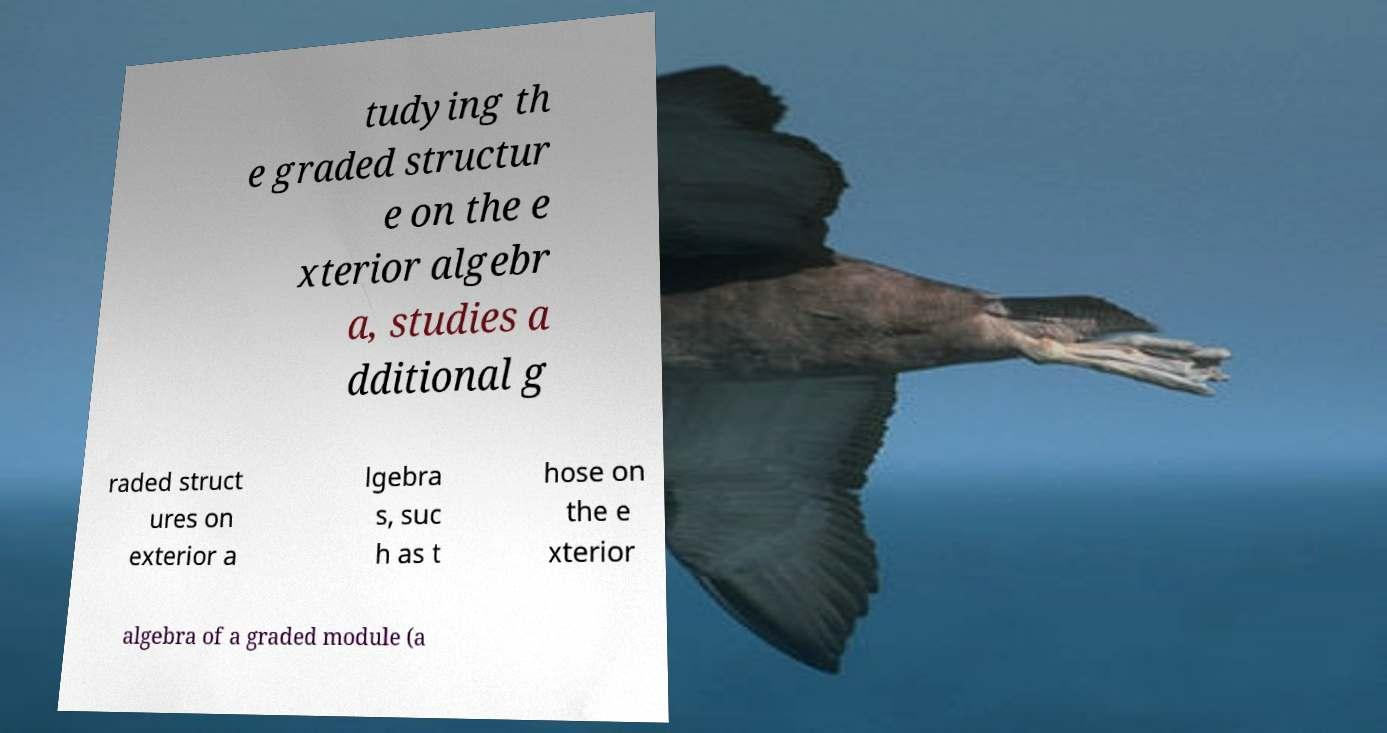I need the written content from this picture converted into text. Can you do that? tudying th e graded structur e on the e xterior algebr a, studies a dditional g raded struct ures on exterior a lgebra s, suc h as t hose on the e xterior algebra of a graded module (a 